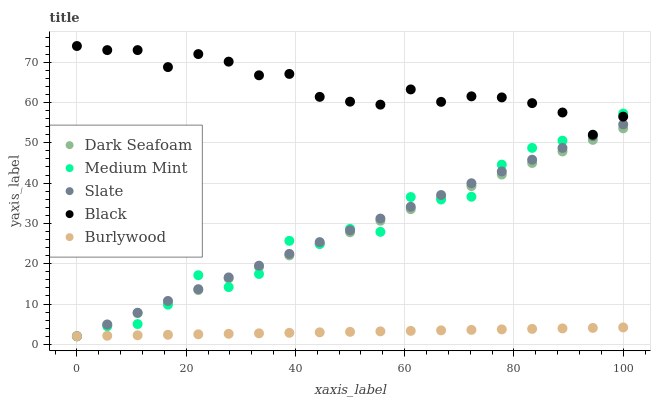Does Burlywood have the minimum area under the curve?
Answer yes or no. Yes. Does Black have the maximum area under the curve?
Answer yes or no. Yes. Does Dark Seafoam have the minimum area under the curve?
Answer yes or no. No. Does Dark Seafoam have the maximum area under the curve?
Answer yes or no. No. Is Burlywood the smoothest?
Answer yes or no. Yes. Is Medium Mint the roughest?
Answer yes or no. Yes. Is Dark Seafoam the smoothest?
Answer yes or no. No. Is Dark Seafoam the roughest?
Answer yes or no. No. Does Medium Mint have the lowest value?
Answer yes or no. Yes. Does Black have the lowest value?
Answer yes or no. No. Does Black have the highest value?
Answer yes or no. Yes. Does Dark Seafoam have the highest value?
Answer yes or no. No. Is Slate less than Black?
Answer yes or no. Yes. Is Black greater than Burlywood?
Answer yes or no. Yes. Does Dark Seafoam intersect Slate?
Answer yes or no. Yes. Is Dark Seafoam less than Slate?
Answer yes or no. No. Is Dark Seafoam greater than Slate?
Answer yes or no. No. Does Slate intersect Black?
Answer yes or no. No. 